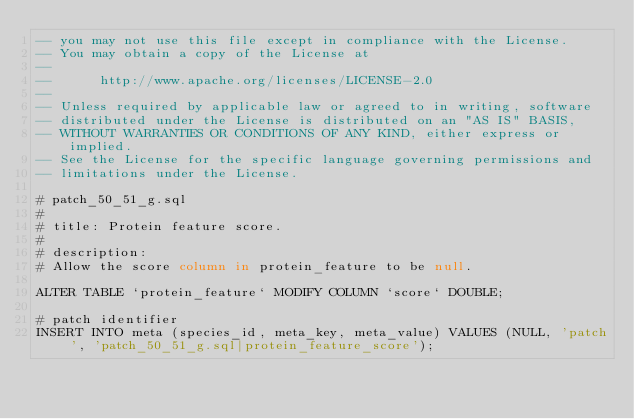Convert code to text. <code><loc_0><loc_0><loc_500><loc_500><_SQL_>-- you may not use this file except in compliance with the License.
-- You may obtain a copy of the License at
-- 
--      http://www.apache.org/licenses/LICENSE-2.0
-- 
-- Unless required by applicable law or agreed to in writing, software
-- distributed under the License is distributed on an "AS IS" BASIS,
-- WITHOUT WARRANTIES OR CONDITIONS OF ANY KIND, either express or implied.
-- See the License for the specific language governing permissions and
-- limitations under the License.

# patch_50_51_g.sql
#
# title: Protein feature score.
#
# description:
# Allow the score column in protein_feature to be null.

ALTER TABLE `protein_feature` MODIFY COLUMN `score` DOUBLE;

# patch identifier
INSERT INTO meta (species_id, meta_key, meta_value) VALUES (NULL, 'patch', 'patch_50_51_g.sql|protein_feature_score');


</code> 